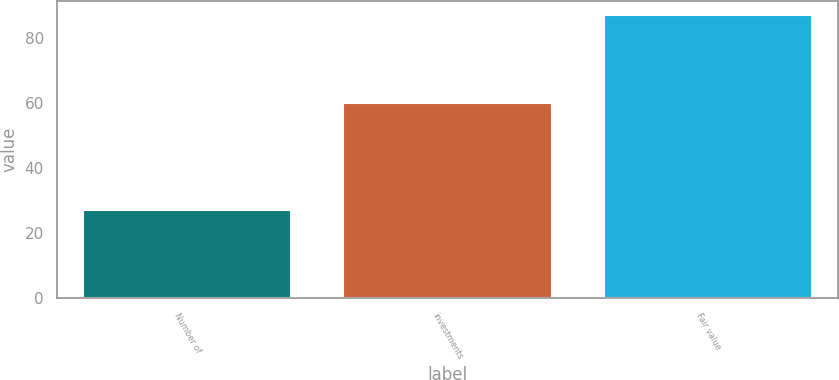Convert chart. <chart><loc_0><loc_0><loc_500><loc_500><bar_chart><fcel>Number of<fcel>investments<fcel>Fair value<nl><fcel>27<fcel>60<fcel>87<nl></chart> 